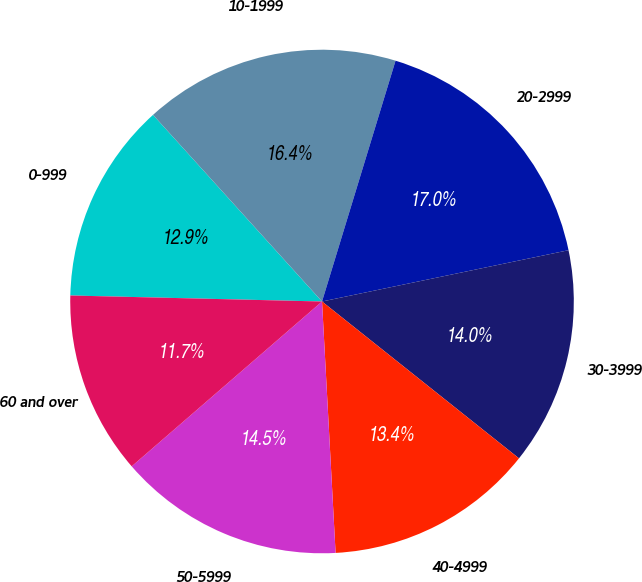<chart> <loc_0><loc_0><loc_500><loc_500><pie_chart><fcel>0-999<fcel>10-1999<fcel>20-2999<fcel>30-3999<fcel>40-4999<fcel>50-5999<fcel>60 and over<nl><fcel>12.91%<fcel>16.43%<fcel>17.02%<fcel>13.97%<fcel>13.44%<fcel>14.5%<fcel>11.74%<nl></chart> 